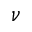<formula> <loc_0><loc_0><loc_500><loc_500>\nu</formula> 